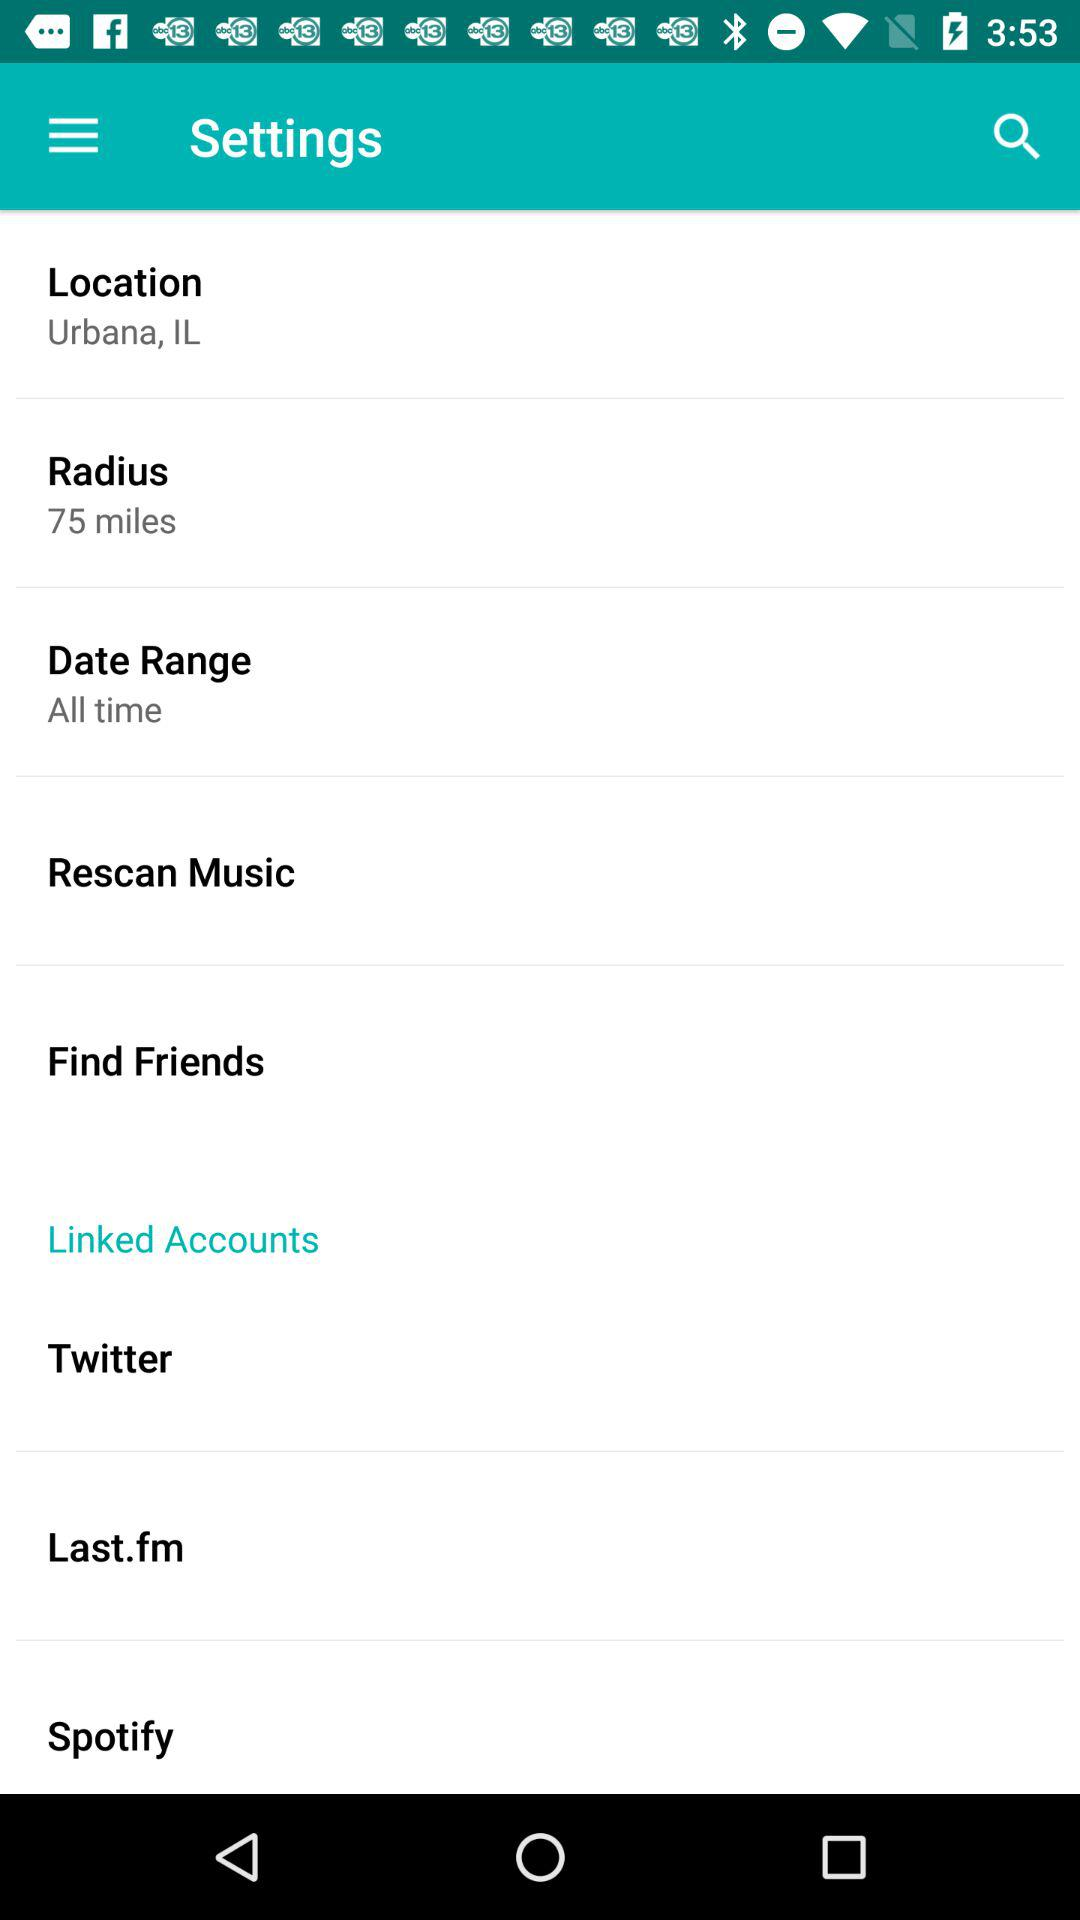Is "Linked Accounts" checked or unchecked?
When the provided information is insufficient, respond with <no answer>. <no answer> 